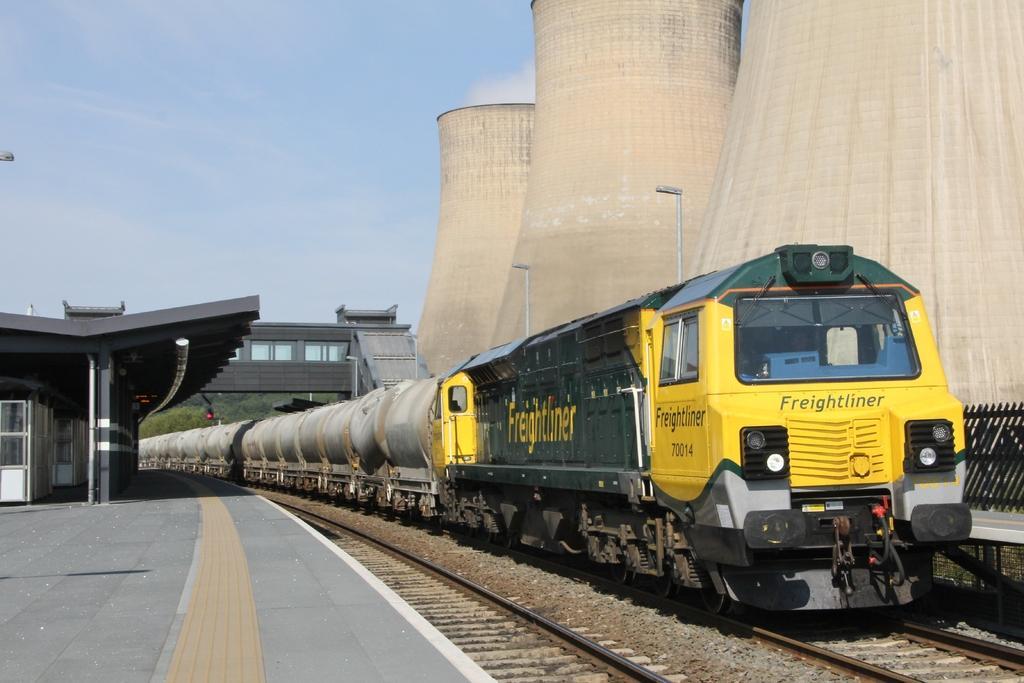Can you describe this image briefly? Here we can see the train on track and we can see platform and shed. background we can see bridge,trees and sky. 